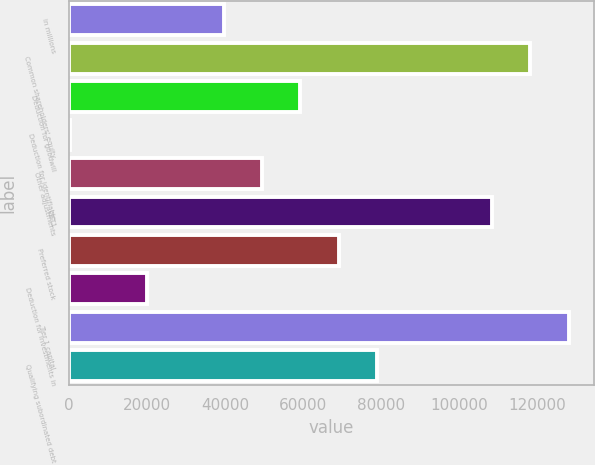<chart> <loc_0><loc_0><loc_500><loc_500><bar_chart><fcel>in millions<fcel>Common shareholders' equity<fcel>Deduction for goodwill<fcel>Deduction for identifiable<fcel>Other adjustments<fcel>CET1<fcel>Preferred stock<fcel>Deduction for investments in<fcel>Tier 1 capital<fcel>Qualifying subordinated debt<nl><fcel>39629.4<fcel>118294<fcel>59295.6<fcel>297<fcel>49462.5<fcel>108461<fcel>69128.7<fcel>19963.2<fcel>128127<fcel>78961.8<nl></chart> 